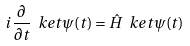Convert formula to latex. <formula><loc_0><loc_0><loc_500><loc_500>i \frac { \partial } { \partial t } \ k e t { \psi ( t ) } = \hat { H } \ k e t { \psi ( t ) }</formula> 